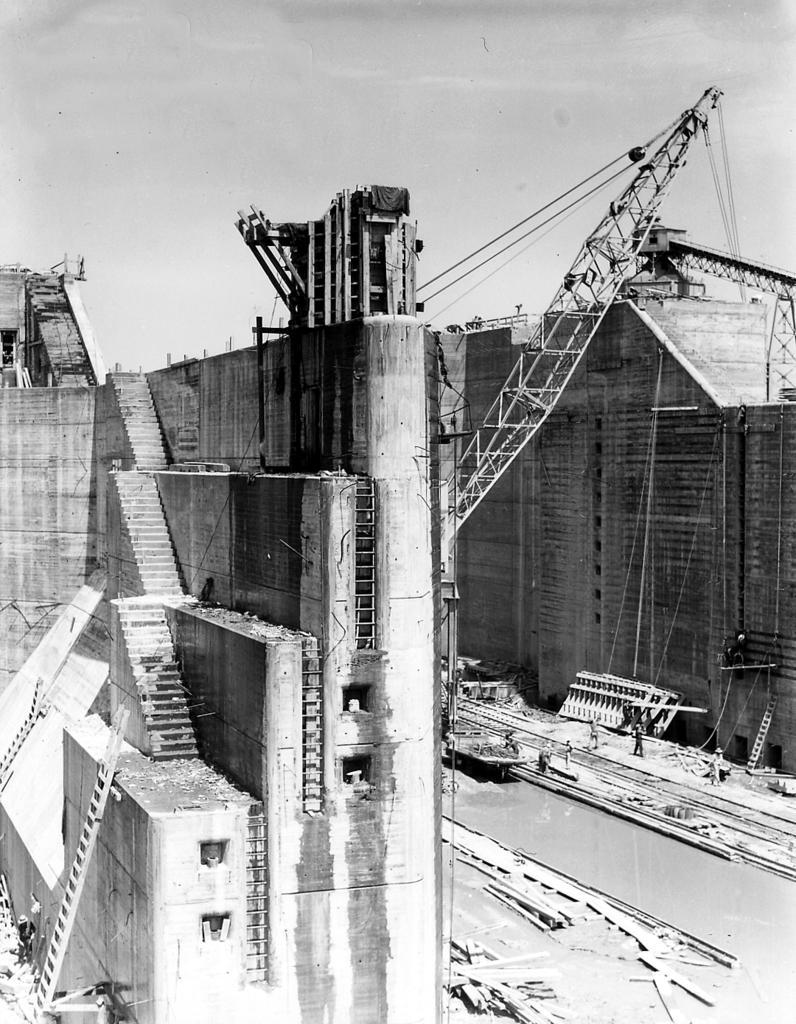How would you summarize this image in a sentence or two? In this picture we can see the black and white photograph of the big wall with steps. Behind there is a crane and on the bottom side there are some persons working. In the background we can see a big wall. 